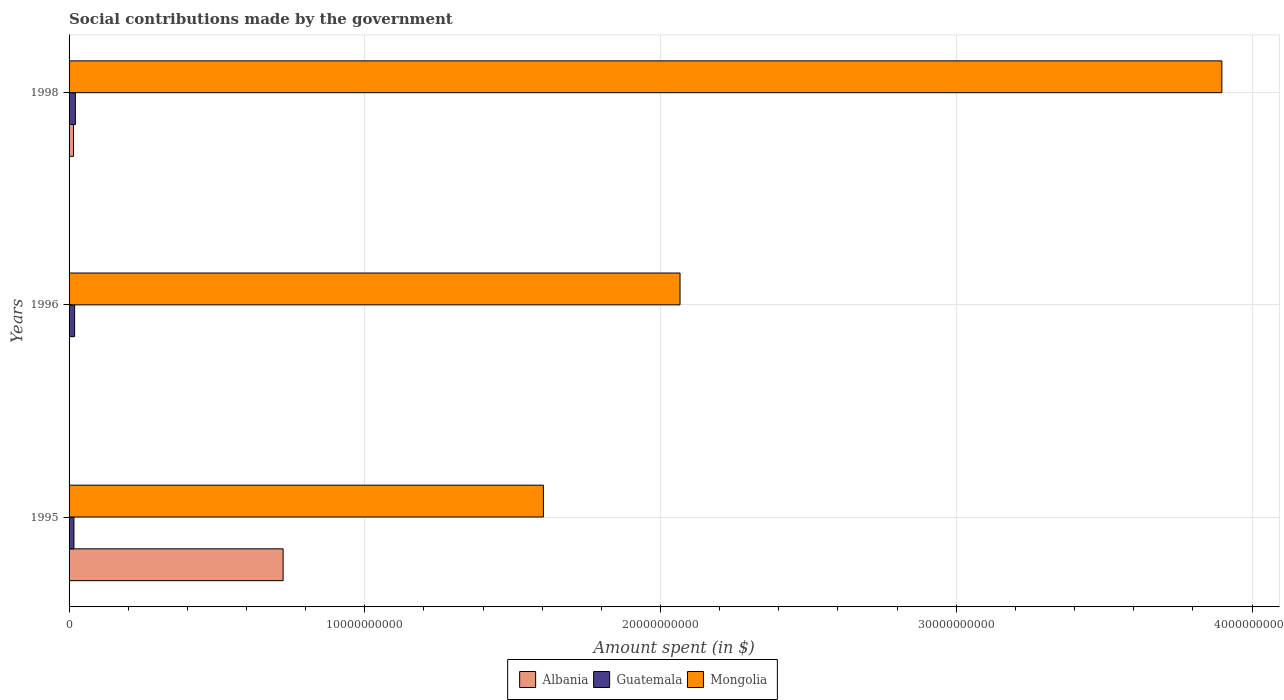How many different coloured bars are there?
Your answer should be very brief. 3. How many groups of bars are there?
Offer a terse response. 3. Are the number of bars per tick equal to the number of legend labels?
Offer a very short reply. Yes. How many bars are there on the 2nd tick from the bottom?
Provide a short and direct response. 3. What is the label of the 3rd group of bars from the top?
Your answer should be compact. 1995. What is the amount spent on social contributions in Albania in 1995?
Provide a short and direct response. 7.24e+09. Across all years, what is the maximum amount spent on social contributions in Mongolia?
Your answer should be compact. 3.90e+1. Across all years, what is the minimum amount spent on social contributions in Mongolia?
Make the answer very short. 1.60e+1. What is the total amount spent on social contributions in Mongolia in the graph?
Offer a very short reply. 7.57e+1. What is the difference between the amount spent on social contributions in Albania in 1995 and that in 1998?
Provide a short and direct response. 7.09e+09. What is the difference between the amount spent on social contributions in Guatemala in 1995 and the amount spent on social contributions in Albania in 1998?
Ensure brevity in your answer.  1.42e+07. What is the average amount spent on social contributions in Albania per year?
Your answer should be compact. 2.46e+09. In the year 1996, what is the difference between the amount spent on social contributions in Guatemala and amount spent on social contributions in Albania?
Offer a very short reply. 1.87e+08. What is the ratio of the amount spent on social contributions in Guatemala in 1995 to that in 1996?
Your answer should be very brief. 0.88. Is the amount spent on social contributions in Albania in 1995 less than that in 1998?
Your answer should be very brief. No. What is the difference between the highest and the second highest amount spent on social contributions in Mongolia?
Offer a very short reply. 1.83e+1. What is the difference between the highest and the lowest amount spent on social contributions in Albania?
Provide a short and direct response. 7.24e+09. In how many years, is the amount spent on social contributions in Albania greater than the average amount spent on social contributions in Albania taken over all years?
Ensure brevity in your answer.  1. Is the sum of the amount spent on social contributions in Mongolia in 1995 and 1996 greater than the maximum amount spent on social contributions in Guatemala across all years?
Offer a terse response. Yes. What does the 3rd bar from the top in 1998 represents?
Give a very brief answer. Albania. What does the 1st bar from the bottom in 1995 represents?
Make the answer very short. Albania. Are all the bars in the graph horizontal?
Provide a short and direct response. Yes. How many years are there in the graph?
Offer a terse response. 3. Are the values on the major ticks of X-axis written in scientific E-notation?
Provide a short and direct response. No. Where does the legend appear in the graph?
Your answer should be very brief. Bottom center. How many legend labels are there?
Your answer should be very brief. 3. What is the title of the graph?
Offer a very short reply. Social contributions made by the government. Does "Northern Mariana Islands" appear as one of the legend labels in the graph?
Your answer should be very brief. No. What is the label or title of the X-axis?
Keep it short and to the point. Amount spent (in $). What is the Amount spent (in $) of Albania in 1995?
Your answer should be compact. 7.24e+09. What is the Amount spent (in $) of Guatemala in 1995?
Make the answer very short. 1.65e+08. What is the Amount spent (in $) of Mongolia in 1995?
Give a very brief answer. 1.60e+1. What is the Amount spent (in $) of Albania in 1996?
Provide a succinct answer. 2000. What is the Amount spent (in $) in Guatemala in 1996?
Give a very brief answer. 1.88e+08. What is the Amount spent (in $) of Mongolia in 1996?
Your answer should be very brief. 2.07e+1. What is the Amount spent (in $) of Albania in 1998?
Your answer should be compact. 1.51e+08. What is the Amount spent (in $) in Guatemala in 1998?
Make the answer very short. 2.13e+08. What is the Amount spent (in $) in Mongolia in 1998?
Your response must be concise. 3.90e+1. Across all years, what is the maximum Amount spent (in $) in Albania?
Your response must be concise. 7.24e+09. Across all years, what is the maximum Amount spent (in $) of Guatemala?
Offer a terse response. 2.13e+08. Across all years, what is the maximum Amount spent (in $) of Mongolia?
Give a very brief answer. 3.90e+1. Across all years, what is the minimum Amount spent (in $) of Guatemala?
Make the answer very short. 1.65e+08. Across all years, what is the minimum Amount spent (in $) in Mongolia?
Your response must be concise. 1.60e+1. What is the total Amount spent (in $) in Albania in the graph?
Make the answer very short. 7.39e+09. What is the total Amount spent (in $) in Guatemala in the graph?
Offer a very short reply. 5.66e+08. What is the total Amount spent (in $) of Mongolia in the graph?
Ensure brevity in your answer.  7.57e+1. What is the difference between the Amount spent (in $) in Albania in 1995 and that in 1996?
Your answer should be very brief. 7.24e+09. What is the difference between the Amount spent (in $) in Guatemala in 1995 and that in 1996?
Ensure brevity in your answer.  -2.26e+07. What is the difference between the Amount spent (in $) in Mongolia in 1995 and that in 1996?
Offer a terse response. -4.62e+09. What is the difference between the Amount spent (in $) of Albania in 1995 and that in 1998?
Ensure brevity in your answer.  7.09e+09. What is the difference between the Amount spent (in $) in Guatemala in 1995 and that in 1998?
Offer a very short reply. -4.83e+07. What is the difference between the Amount spent (in $) in Mongolia in 1995 and that in 1998?
Offer a very short reply. -2.29e+1. What is the difference between the Amount spent (in $) of Albania in 1996 and that in 1998?
Your answer should be compact. -1.51e+08. What is the difference between the Amount spent (in $) of Guatemala in 1996 and that in 1998?
Your answer should be very brief. -2.57e+07. What is the difference between the Amount spent (in $) in Mongolia in 1996 and that in 1998?
Provide a short and direct response. -1.83e+1. What is the difference between the Amount spent (in $) in Albania in 1995 and the Amount spent (in $) in Guatemala in 1996?
Offer a terse response. 7.05e+09. What is the difference between the Amount spent (in $) in Albania in 1995 and the Amount spent (in $) in Mongolia in 1996?
Provide a succinct answer. -1.34e+1. What is the difference between the Amount spent (in $) of Guatemala in 1995 and the Amount spent (in $) of Mongolia in 1996?
Give a very brief answer. -2.05e+1. What is the difference between the Amount spent (in $) of Albania in 1995 and the Amount spent (in $) of Guatemala in 1998?
Ensure brevity in your answer.  7.02e+09. What is the difference between the Amount spent (in $) of Albania in 1995 and the Amount spent (in $) of Mongolia in 1998?
Ensure brevity in your answer.  -3.17e+1. What is the difference between the Amount spent (in $) in Guatemala in 1995 and the Amount spent (in $) in Mongolia in 1998?
Keep it short and to the point. -3.88e+1. What is the difference between the Amount spent (in $) in Albania in 1996 and the Amount spent (in $) in Guatemala in 1998?
Offer a very short reply. -2.13e+08. What is the difference between the Amount spent (in $) of Albania in 1996 and the Amount spent (in $) of Mongolia in 1998?
Give a very brief answer. -3.90e+1. What is the difference between the Amount spent (in $) in Guatemala in 1996 and the Amount spent (in $) in Mongolia in 1998?
Make the answer very short. -3.88e+1. What is the average Amount spent (in $) of Albania per year?
Your answer should be compact. 2.46e+09. What is the average Amount spent (in $) of Guatemala per year?
Provide a succinct answer. 1.89e+08. What is the average Amount spent (in $) of Mongolia per year?
Offer a very short reply. 2.52e+1. In the year 1995, what is the difference between the Amount spent (in $) in Albania and Amount spent (in $) in Guatemala?
Your answer should be very brief. 7.07e+09. In the year 1995, what is the difference between the Amount spent (in $) of Albania and Amount spent (in $) of Mongolia?
Offer a very short reply. -8.80e+09. In the year 1995, what is the difference between the Amount spent (in $) of Guatemala and Amount spent (in $) of Mongolia?
Offer a very short reply. -1.59e+1. In the year 1996, what is the difference between the Amount spent (in $) of Albania and Amount spent (in $) of Guatemala?
Your answer should be compact. -1.87e+08. In the year 1996, what is the difference between the Amount spent (in $) in Albania and Amount spent (in $) in Mongolia?
Make the answer very short. -2.07e+1. In the year 1996, what is the difference between the Amount spent (in $) of Guatemala and Amount spent (in $) of Mongolia?
Make the answer very short. -2.05e+1. In the year 1998, what is the difference between the Amount spent (in $) of Albania and Amount spent (in $) of Guatemala?
Offer a terse response. -6.25e+07. In the year 1998, what is the difference between the Amount spent (in $) in Albania and Amount spent (in $) in Mongolia?
Keep it short and to the point. -3.88e+1. In the year 1998, what is the difference between the Amount spent (in $) in Guatemala and Amount spent (in $) in Mongolia?
Offer a very short reply. -3.88e+1. What is the ratio of the Amount spent (in $) of Albania in 1995 to that in 1996?
Ensure brevity in your answer.  3.62e+06. What is the ratio of the Amount spent (in $) in Guatemala in 1995 to that in 1996?
Your answer should be compact. 0.88. What is the ratio of the Amount spent (in $) in Mongolia in 1995 to that in 1996?
Your answer should be very brief. 0.78. What is the ratio of the Amount spent (in $) in Albania in 1995 to that in 1998?
Offer a very short reply. 48.03. What is the ratio of the Amount spent (in $) of Guatemala in 1995 to that in 1998?
Your answer should be compact. 0.77. What is the ratio of the Amount spent (in $) in Mongolia in 1995 to that in 1998?
Ensure brevity in your answer.  0.41. What is the ratio of the Amount spent (in $) of Albania in 1996 to that in 1998?
Your answer should be compact. 0. What is the ratio of the Amount spent (in $) of Guatemala in 1996 to that in 1998?
Offer a very short reply. 0.88. What is the ratio of the Amount spent (in $) of Mongolia in 1996 to that in 1998?
Offer a terse response. 0.53. What is the difference between the highest and the second highest Amount spent (in $) in Albania?
Provide a succinct answer. 7.09e+09. What is the difference between the highest and the second highest Amount spent (in $) in Guatemala?
Ensure brevity in your answer.  2.57e+07. What is the difference between the highest and the second highest Amount spent (in $) in Mongolia?
Provide a succinct answer. 1.83e+1. What is the difference between the highest and the lowest Amount spent (in $) in Albania?
Your response must be concise. 7.24e+09. What is the difference between the highest and the lowest Amount spent (in $) in Guatemala?
Provide a short and direct response. 4.83e+07. What is the difference between the highest and the lowest Amount spent (in $) in Mongolia?
Your answer should be compact. 2.29e+1. 